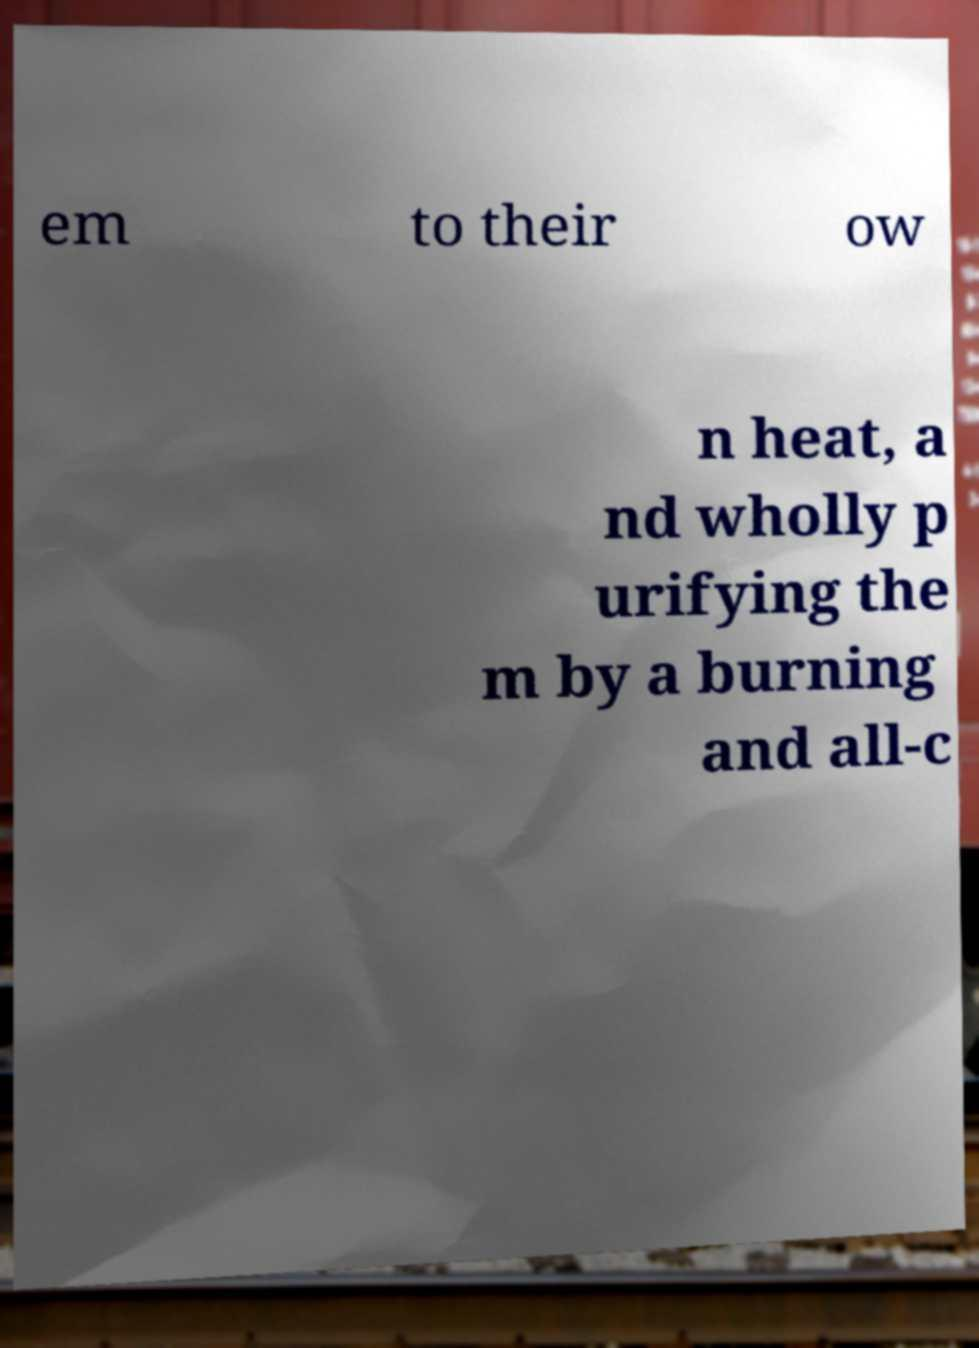Can you accurately transcribe the text from the provided image for me? em to their ow n heat, a nd wholly p urifying the m by a burning and all-c 